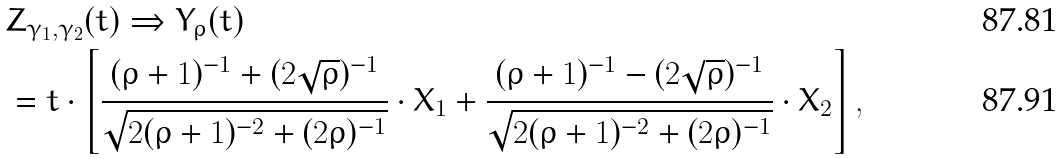Convert formula to latex. <formula><loc_0><loc_0><loc_500><loc_500>& Z _ { \gamma _ { 1 } , \gamma _ { 2 } } ( t ) \Rightarrow Y _ { \rho } ( t ) \\ & = t \cdot \left [ \frac { ( \rho + 1 ) ^ { - 1 } + ( 2 \sqrt { \rho } ) ^ { - 1 } } { \sqrt { 2 ( \rho + 1 ) ^ { - 2 } + ( 2 \rho ) ^ { - 1 } } } \cdot X _ { 1 } + \frac { ( \rho + 1 ) ^ { - 1 } - ( 2 \sqrt { \rho } ) ^ { - 1 } } { \sqrt { 2 ( \rho + 1 ) ^ { - 2 } + ( 2 \rho ) ^ { - 1 } } } \cdot X _ { 2 } \right ] ,</formula> 